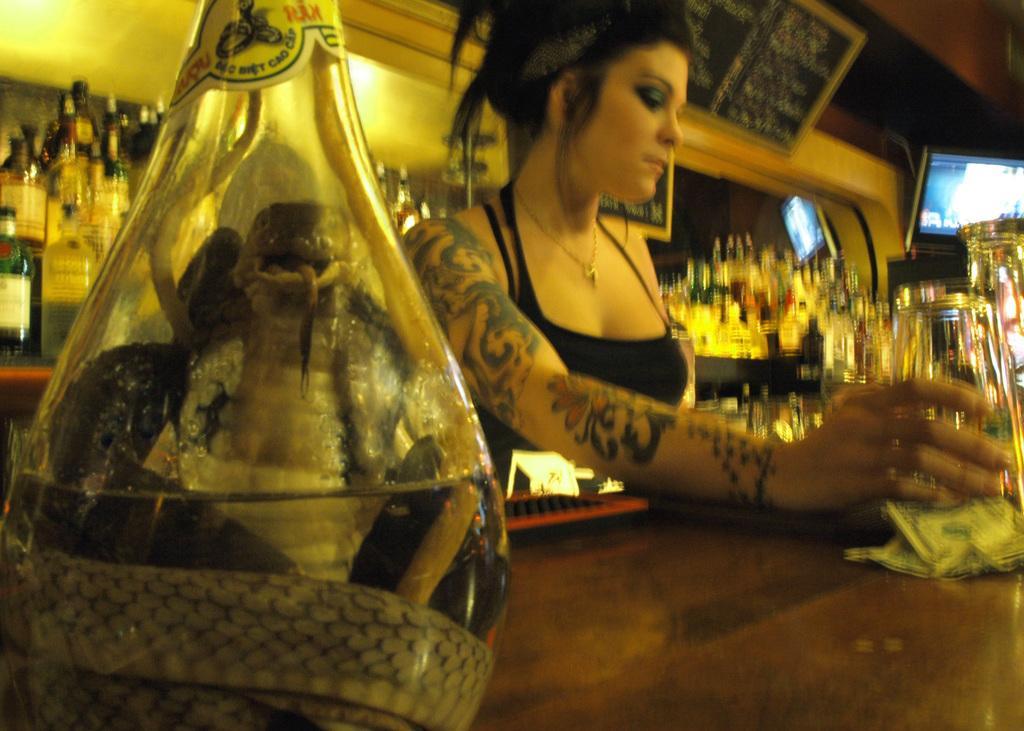Describe this image in one or two sentences. In the image we can see there is a woman who is holding a glass and in a flask there is a snake and at the back there are lot of bottles and there is a tattoo on woman's hand. 